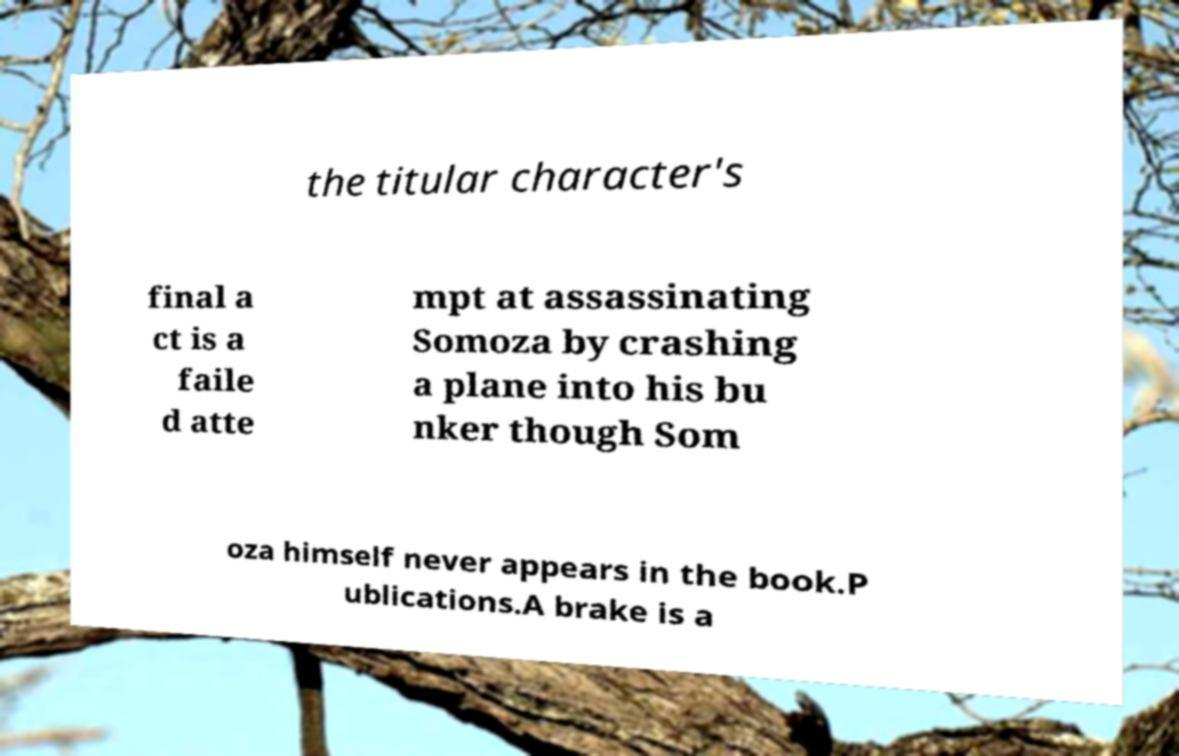There's text embedded in this image that I need extracted. Can you transcribe it verbatim? the titular character's final a ct is a faile d atte mpt at assassinating Somoza by crashing a plane into his bu nker though Som oza himself never appears in the book.P ublications.A brake is a 